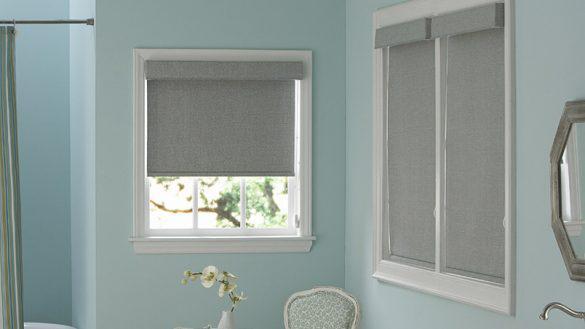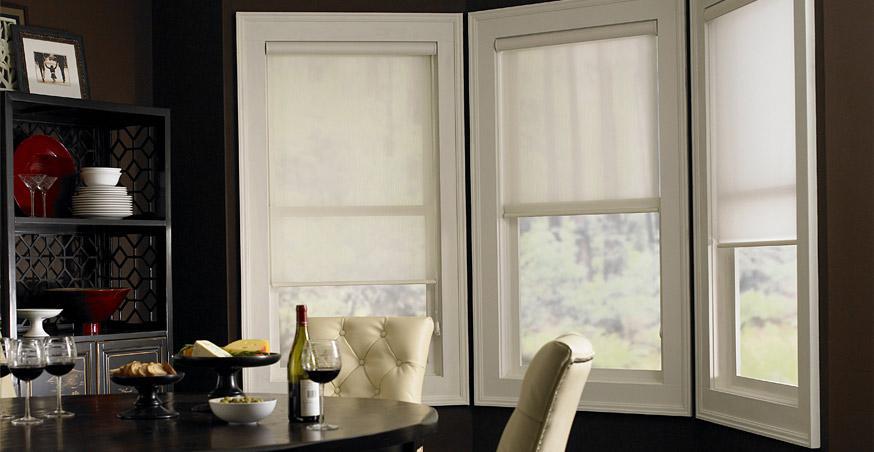The first image is the image on the left, the second image is the image on the right. Given the left and right images, does the statement "There are five blinds." hold true? Answer yes or no. No. The first image is the image on the left, the second image is the image on the right. Analyze the images presented: Is the assertion "All the window shades are partially open." valid? Answer yes or no. No. 